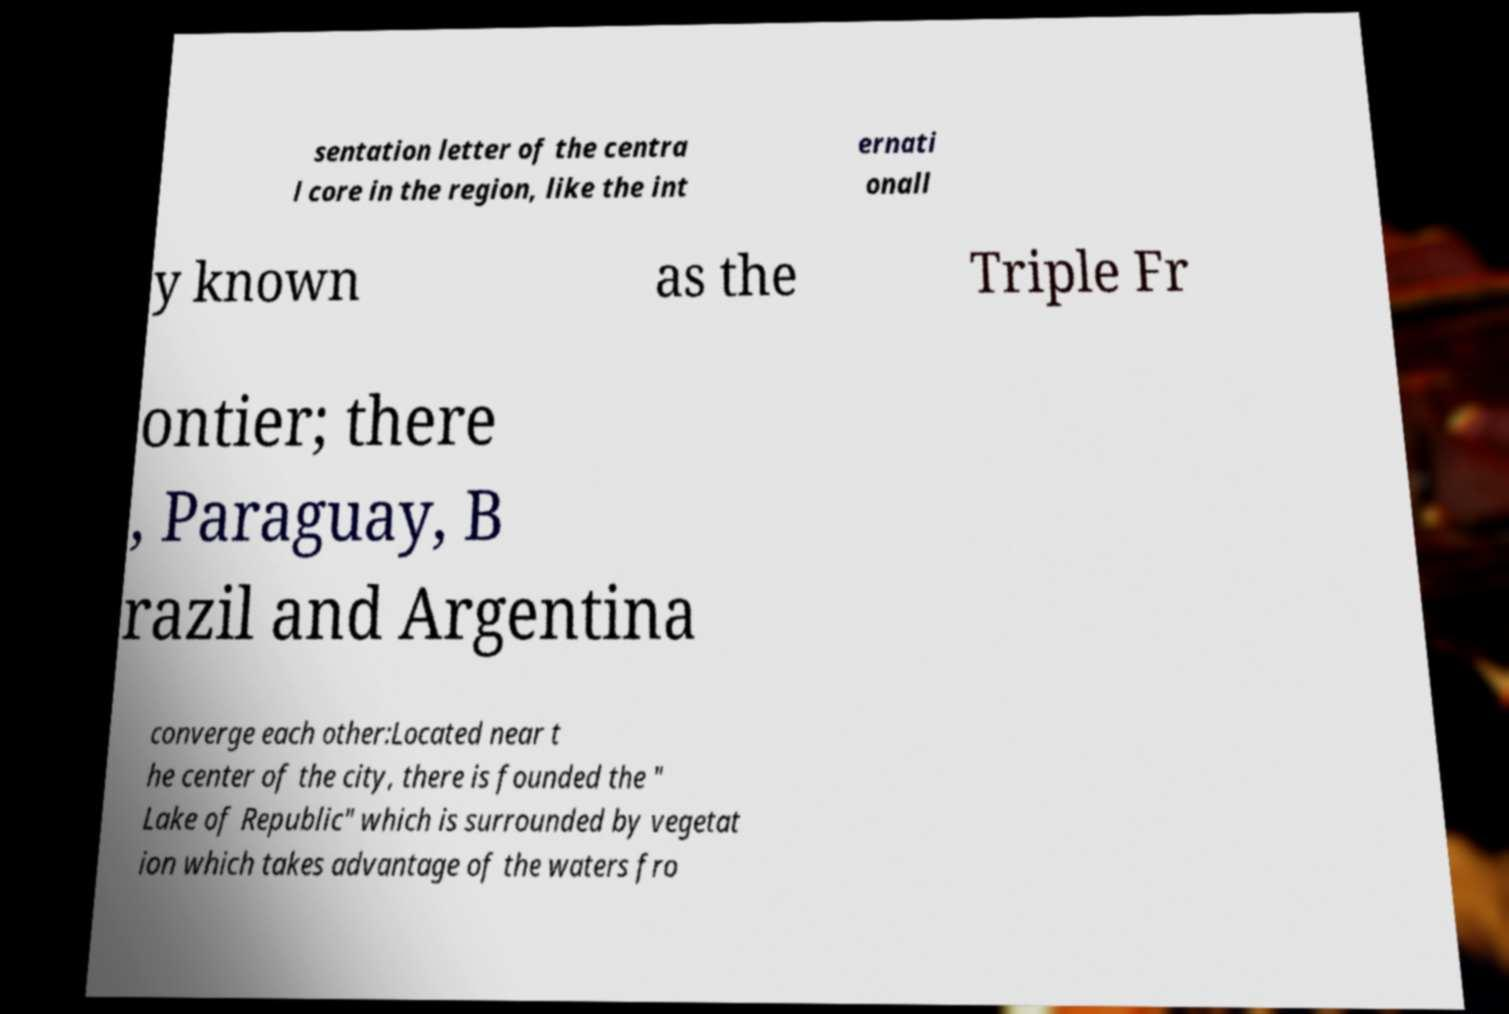I need the written content from this picture converted into text. Can you do that? sentation letter of the centra l core in the region, like the int ernati onall y known as the Triple Fr ontier; there , Paraguay, B razil and Argentina converge each other:Located near t he center of the city, there is founded the " Lake of Republic" which is surrounded by vegetat ion which takes advantage of the waters fro 